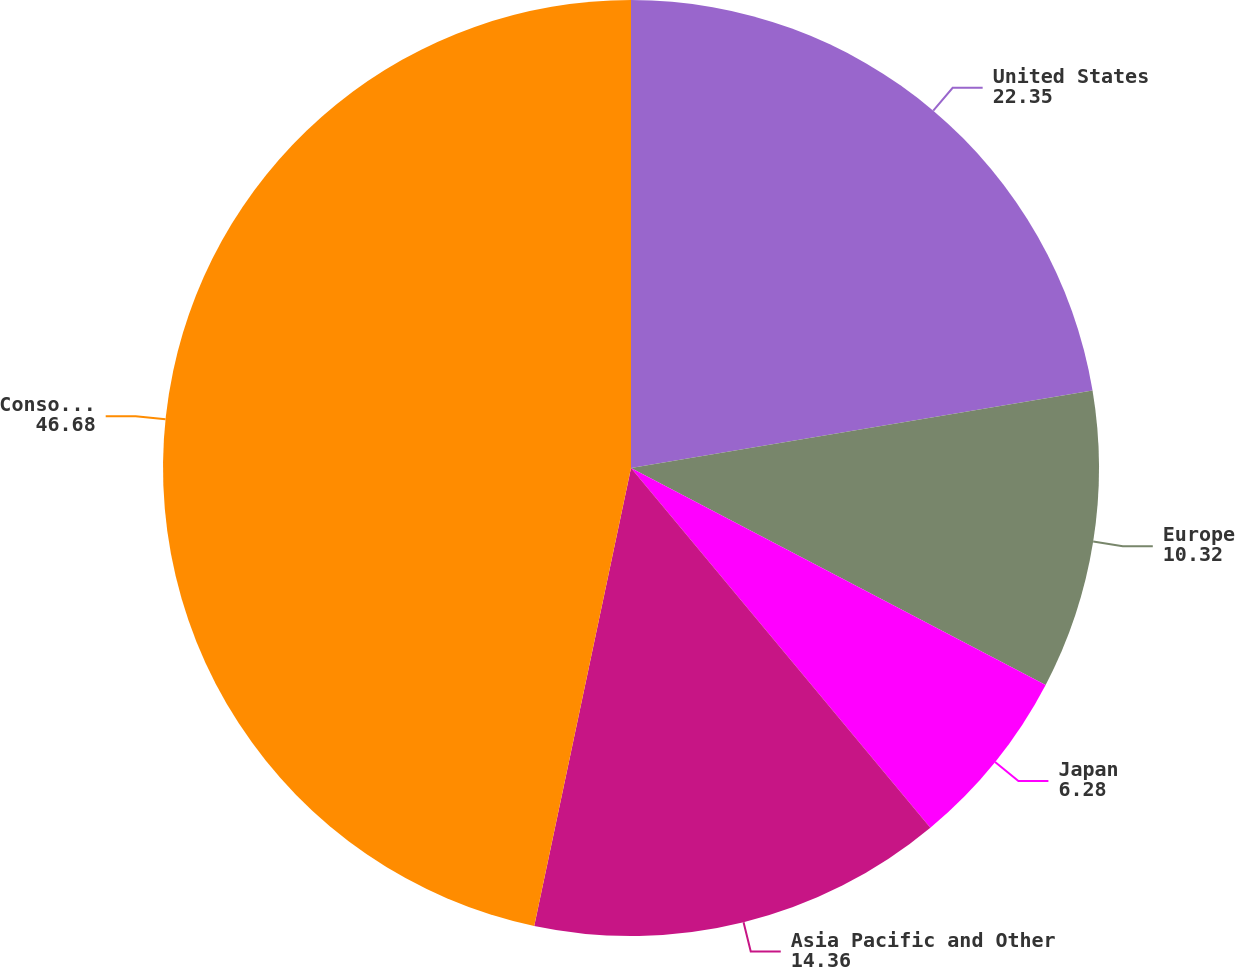<chart> <loc_0><loc_0><loc_500><loc_500><pie_chart><fcel>United States<fcel>Europe<fcel>Japan<fcel>Asia Pacific and Other<fcel>Consolidated<nl><fcel>22.35%<fcel>10.32%<fcel>6.28%<fcel>14.36%<fcel>46.68%<nl></chart> 